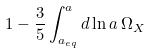Convert formula to latex. <formula><loc_0><loc_0><loc_500><loc_500>1 - \frac { 3 } { 5 } \int _ { a _ { e q } } ^ { a } d \ln a \, \Omega _ { X }</formula> 